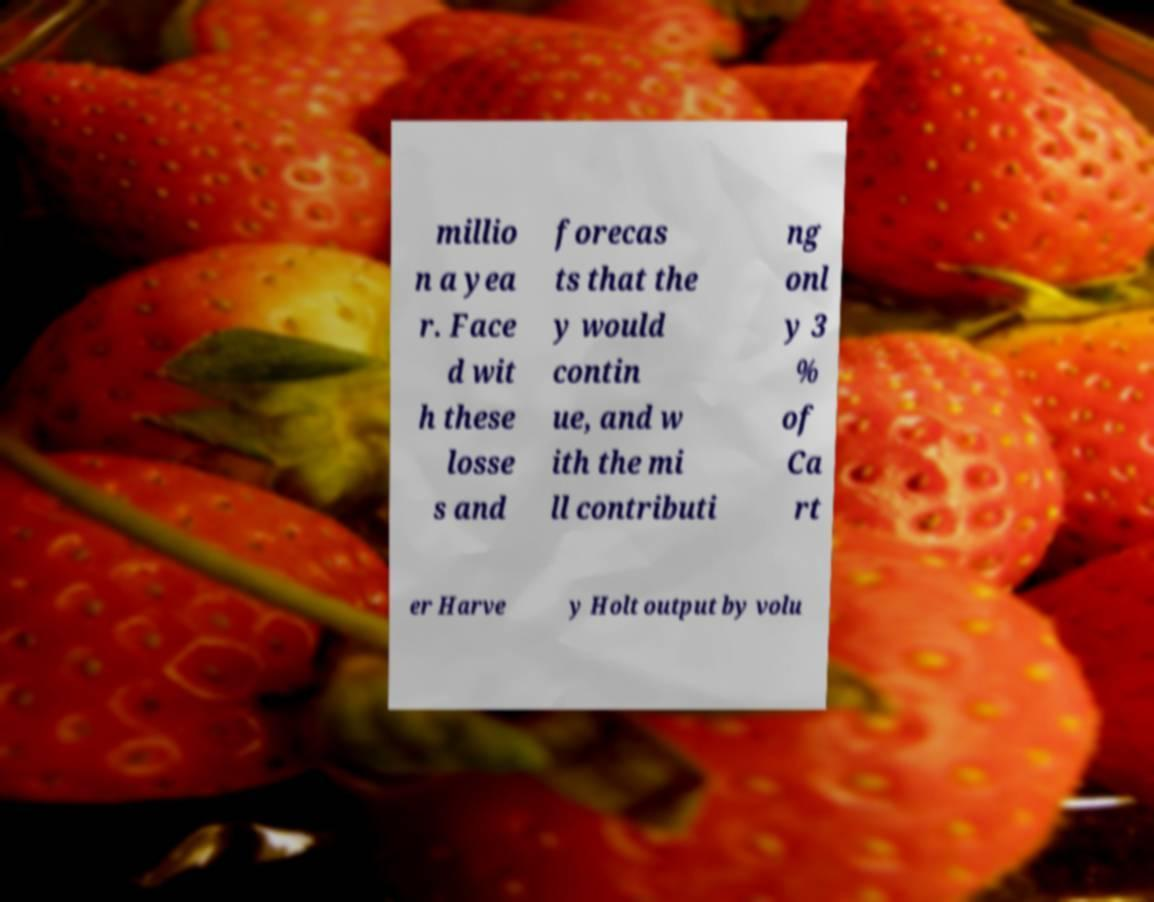I need the written content from this picture converted into text. Can you do that? millio n a yea r. Face d wit h these losse s and forecas ts that the y would contin ue, and w ith the mi ll contributi ng onl y 3 % of Ca rt er Harve y Holt output by volu 